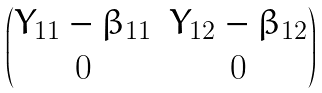<formula> <loc_0><loc_0><loc_500><loc_500>\begin{pmatrix} Y _ { 1 1 } - \beta _ { 1 1 } & Y _ { 1 2 } - \beta _ { 1 2 } \\ 0 & 0 \end{pmatrix}</formula> 